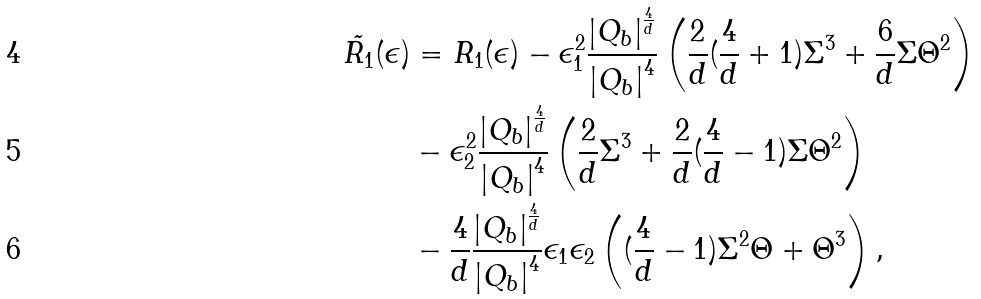Convert formula to latex. <formula><loc_0><loc_0><loc_500><loc_500>\tilde { R _ { 1 } } ( \epsilon ) & = R _ { 1 } ( \epsilon ) - \epsilon _ { 1 } ^ { 2 } \frac { \left | Q _ { b } \right | ^ { \frac { 4 } { d } } } { \left | Q _ { b } \right | ^ { 4 } } \left ( \frac { 2 } { d } ( \frac { 4 } { d } + 1 ) \Sigma ^ { 3 } + \frac { 6 } { d } \Sigma \Theta ^ { 2 } \right ) \\ & - \epsilon _ { 2 } ^ { 2 } \frac { \left | Q _ { b } \right | ^ { \frac { 4 } { d } } } { \left | Q _ { b } \right | ^ { 4 } } \left ( \frac { 2 } { d } \Sigma ^ { 3 } + \frac { 2 } { d } ( \frac { 4 } { d } - 1 ) \Sigma \Theta ^ { 2 } \right ) \\ & - \frac { 4 } { d } \frac { \left | Q _ { b } \right | ^ { \frac { 4 } { d } } } { \left | Q _ { b } \right | ^ { 4 } } \epsilon _ { 1 } \epsilon _ { 2 } \left ( ( \frac { 4 } { d } - 1 ) \Sigma ^ { 2 } \Theta + \Theta ^ { 3 } \right ) ,</formula> 